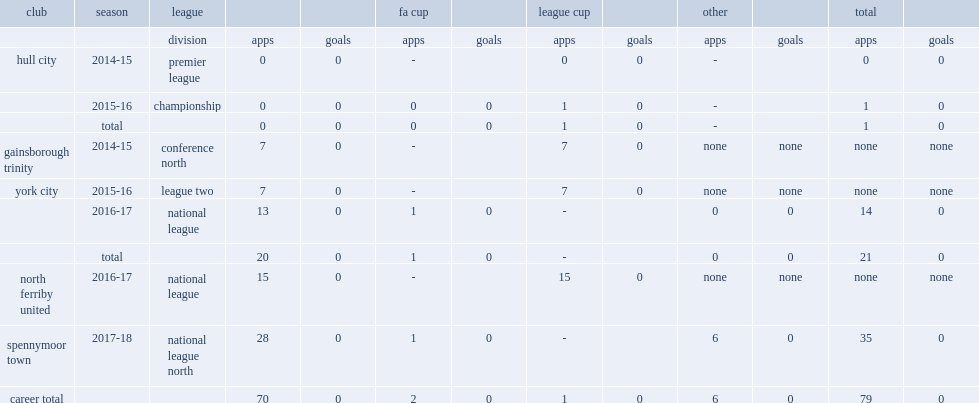Which club did matty dixon play for in 2015-16? York city. 